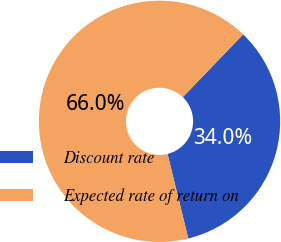Convert chart to OTSL. <chart><loc_0><loc_0><loc_500><loc_500><pie_chart><fcel>Discount rate<fcel>Expected rate of return on<nl><fcel>33.98%<fcel>66.02%<nl></chart> 